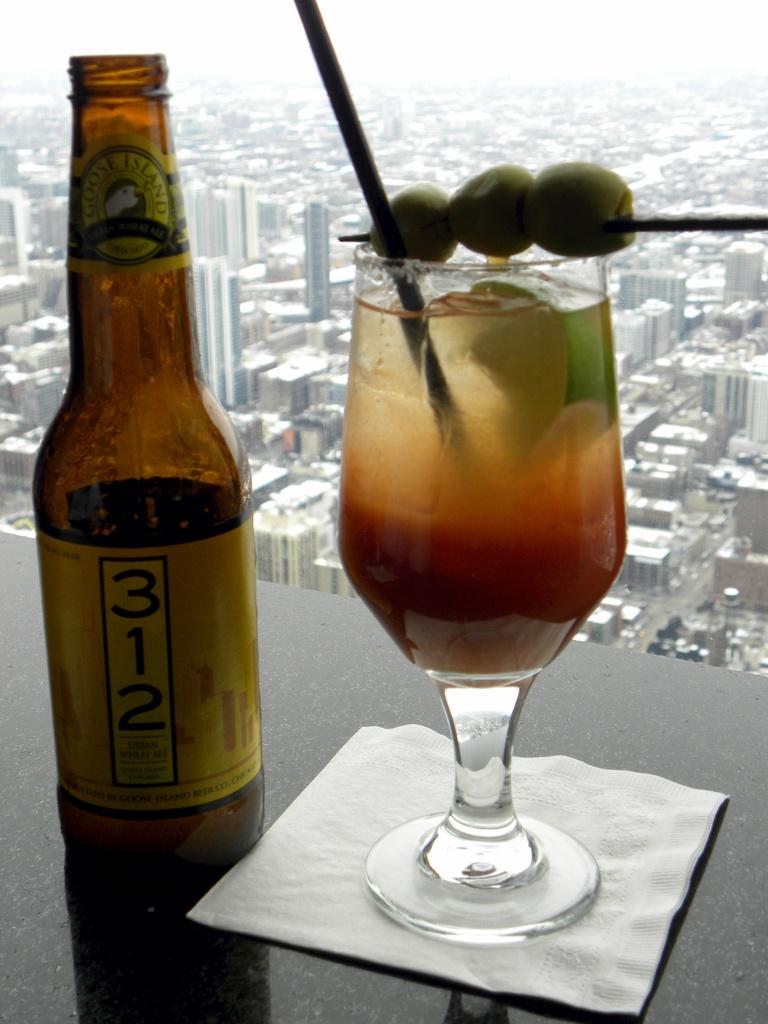What number on the bottle?
Your answer should be very brief. 312. 